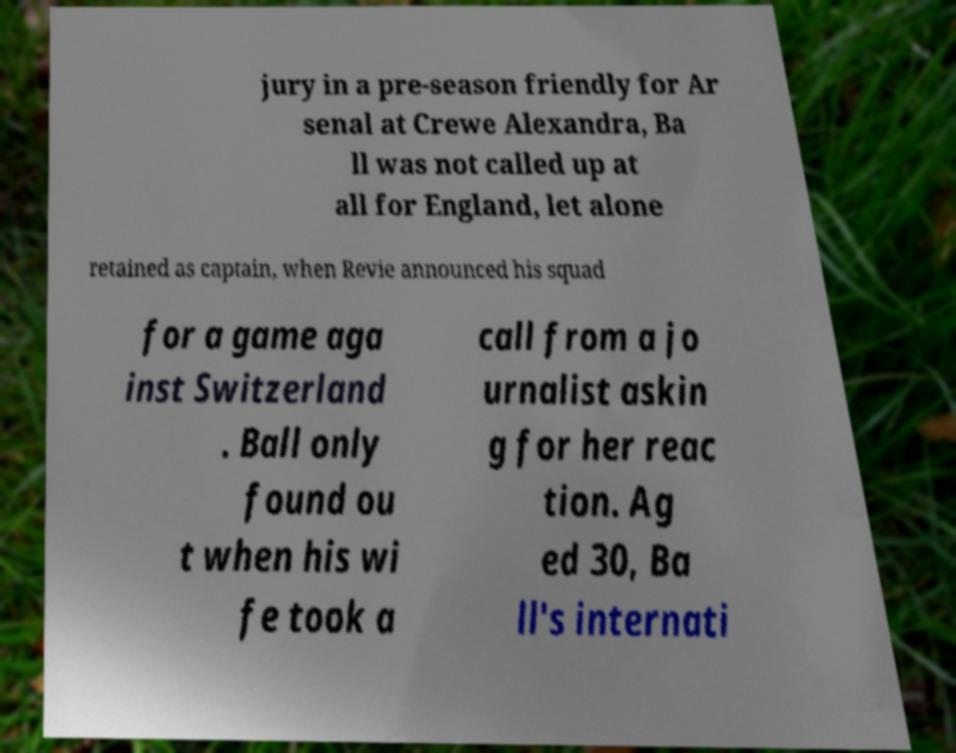Could you extract and type out the text from this image? jury in a pre-season friendly for Ar senal at Crewe Alexandra, Ba ll was not called up at all for England, let alone retained as captain, when Revie announced his squad for a game aga inst Switzerland . Ball only found ou t when his wi fe took a call from a jo urnalist askin g for her reac tion. Ag ed 30, Ba ll's internati 